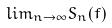Convert formula to latex. <formula><loc_0><loc_0><loc_500><loc_500>l i m _ { n \rightarrow \infty } S _ { n } ( f )</formula> 